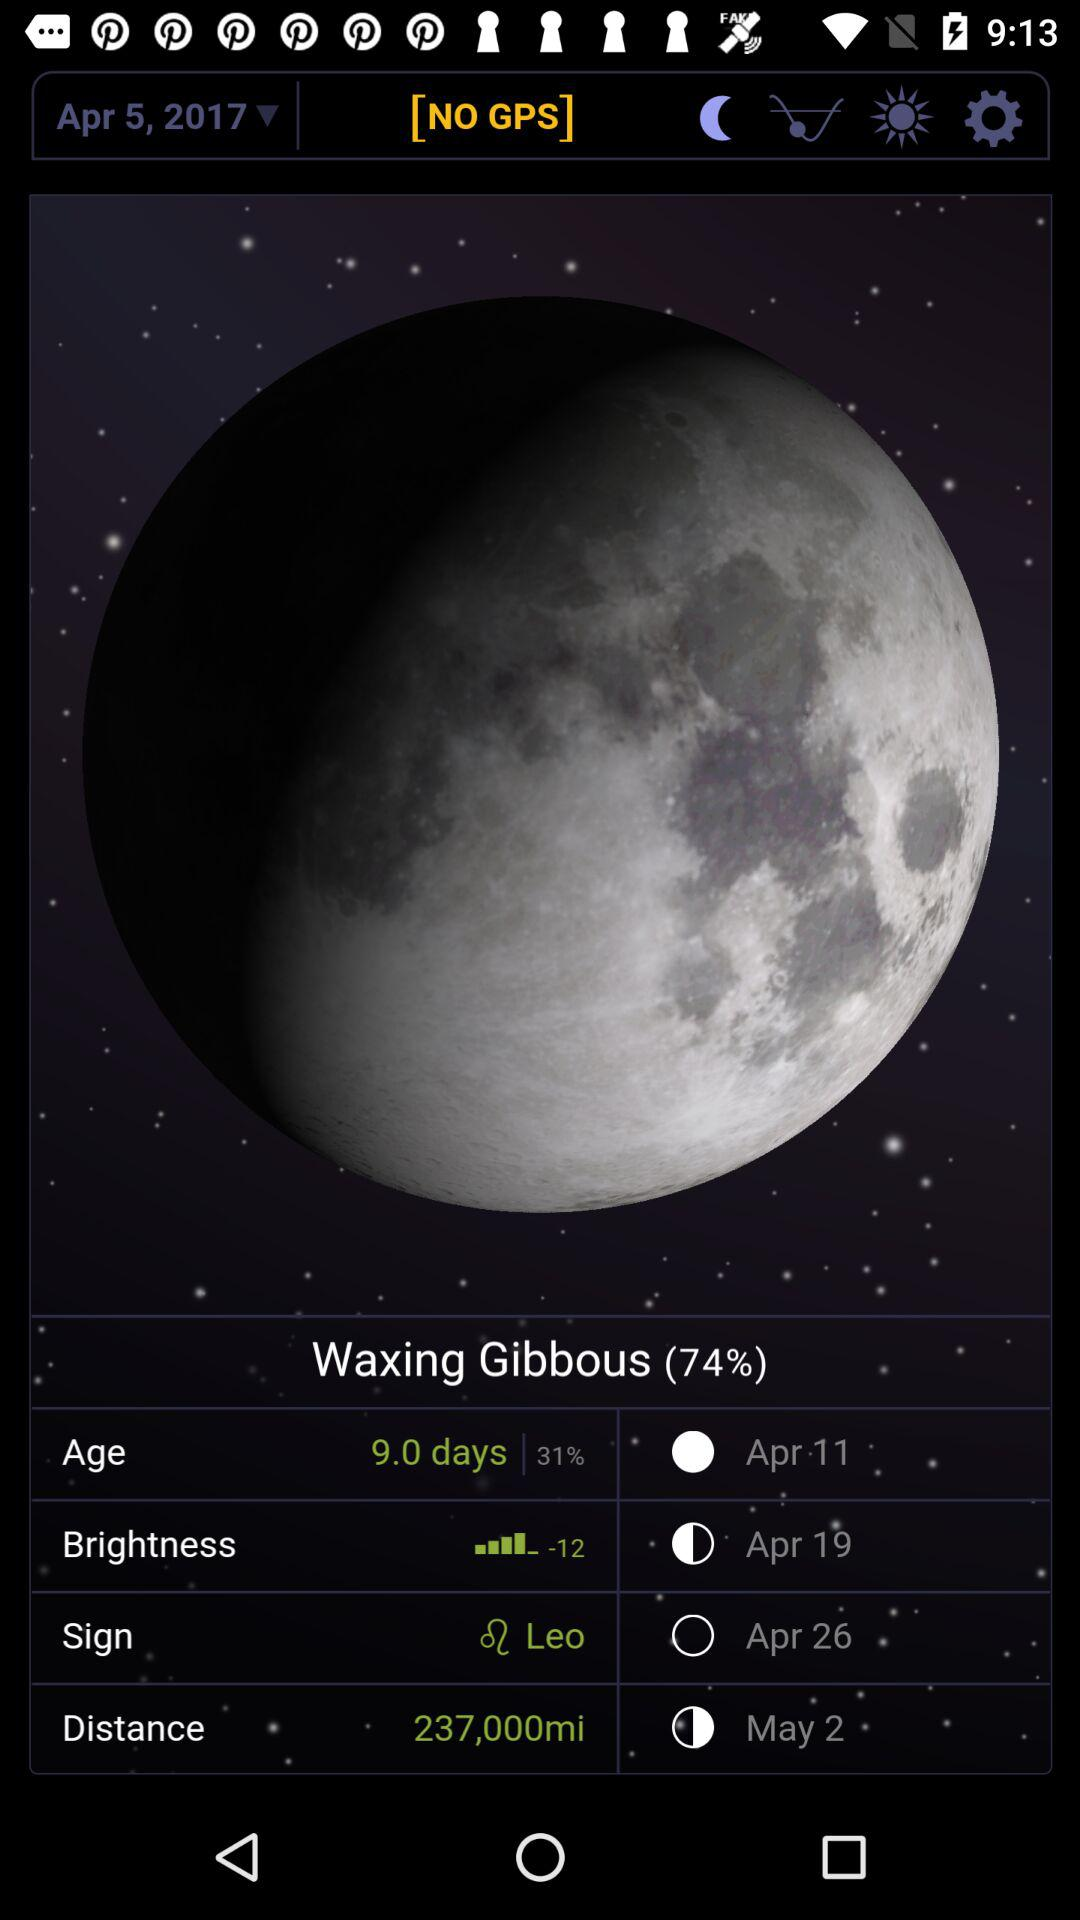What is the sign? The sign is Leo. 